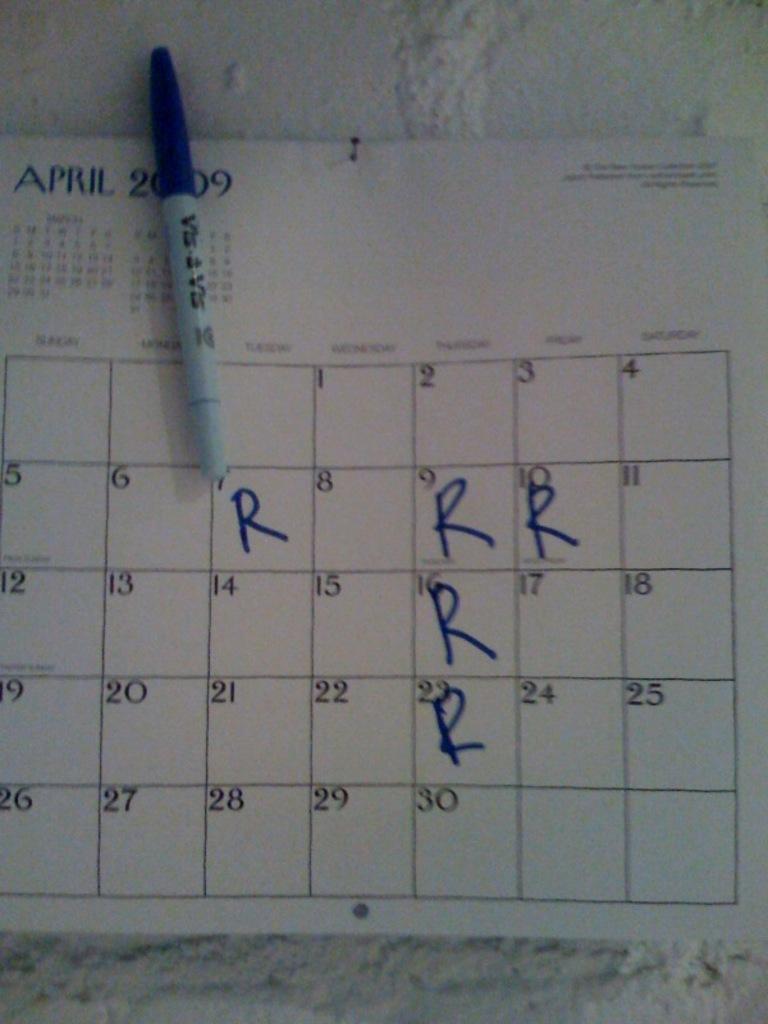Can you describe this image briefly? In this image I see a calendar on which there is a word and numbers written on it and I see a marker over here and I see that there is an alphabet "R" written on few dates and I see that this calendar is on the white surface. 